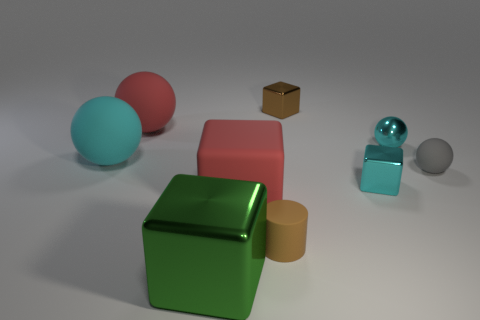Is the number of tiny brown metallic blocks that are behind the tiny metallic sphere greater than the number of small blue matte blocks?
Make the answer very short. Yes. How many other cyan cubes are the same size as the rubber cube?
Offer a terse response. 0. Is the size of the red rubber object in front of the tiny cyan metallic cube the same as the cyan cube that is left of the cyan metallic ball?
Provide a succinct answer. No. There is a metallic cube that is in front of the tiny brown rubber thing; how big is it?
Keep it short and to the point. Large. There is a matte sphere right of the big rubber thing that is right of the green metallic thing; what size is it?
Keep it short and to the point. Small. What material is the gray sphere that is the same size as the cyan shiny sphere?
Provide a short and direct response. Rubber. There is a green block; are there any small metal cubes right of it?
Your answer should be very brief. Yes. Is the number of large red things that are in front of the small shiny sphere the same as the number of cyan blocks?
Your answer should be very brief. Yes. There is a gray thing that is the same size as the brown shiny object; what is its shape?
Ensure brevity in your answer.  Sphere. What is the material of the green object?
Keep it short and to the point. Metal. 